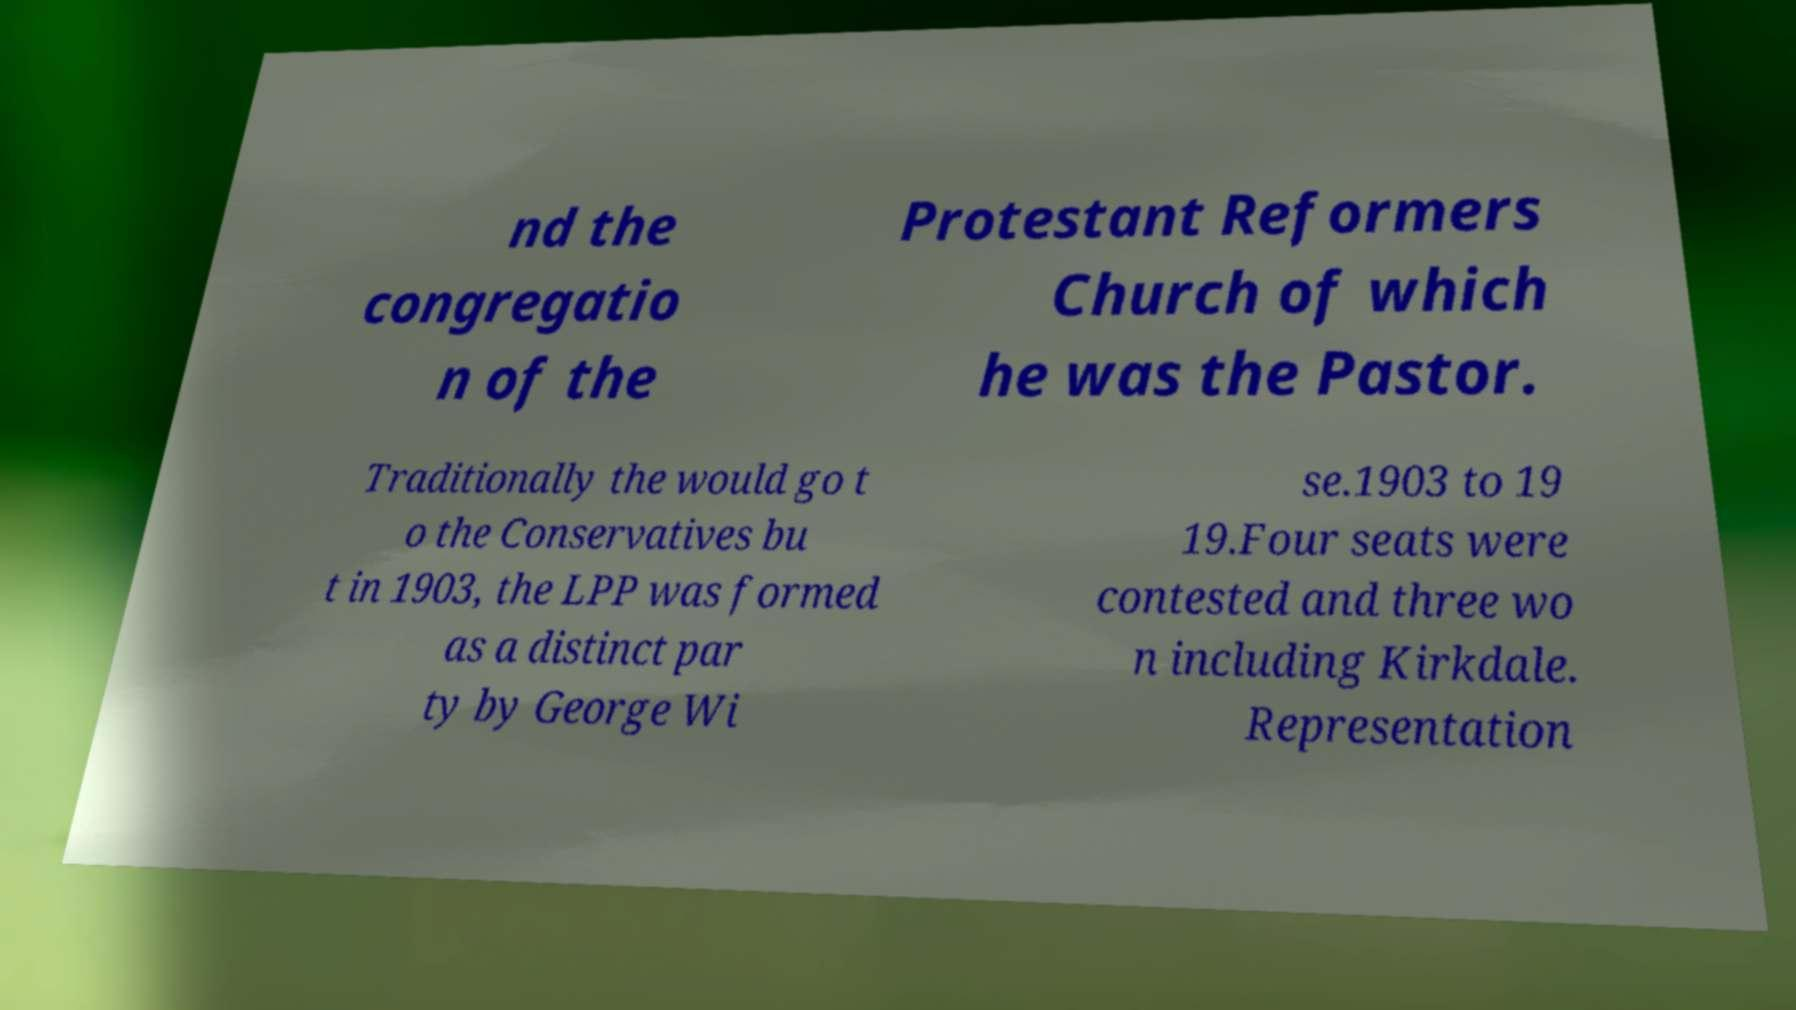Can you accurately transcribe the text from the provided image for me? nd the congregatio n of the Protestant Reformers Church of which he was the Pastor. Traditionally the would go t o the Conservatives bu t in 1903, the LPP was formed as a distinct par ty by George Wi se.1903 to 19 19.Four seats were contested and three wo n including Kirkdale. Representation 